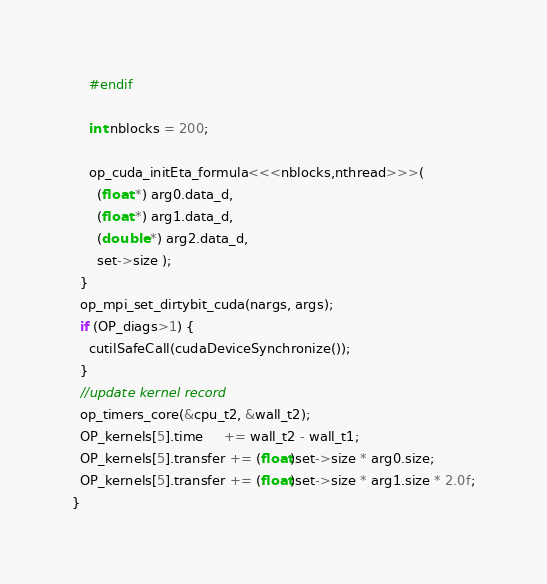<code> <loc_0><loc_0><loc_500><loc_500><_Cuda_>    #endif

    int nblocks = 200;

    op_cuda_initEta_formula<<<nblocks,nthread>>>(
      (float *) arg0.data_d,
      (float *) arg1.data_d,
      (double *) arg2.data_d,
      set->size );
  }
  op_mpi_set_dirtybit_cuda(nargs, args);
  if (OP_diags>1) {
    cutilSafeCall(cudaDeviceSynchronize());
  }
  //update kernel record
  op_timers_core(&cpu_t2, &wall_t2);
  OP_kernels[5].time     += wall_t2 - wall_t1;
  OP_kernels[5].transfer += (float)set->size * arg0.size;
  OP_kernels[5].transfer += (float)set->size * arg1.size * 2.0f;
}
</code> 